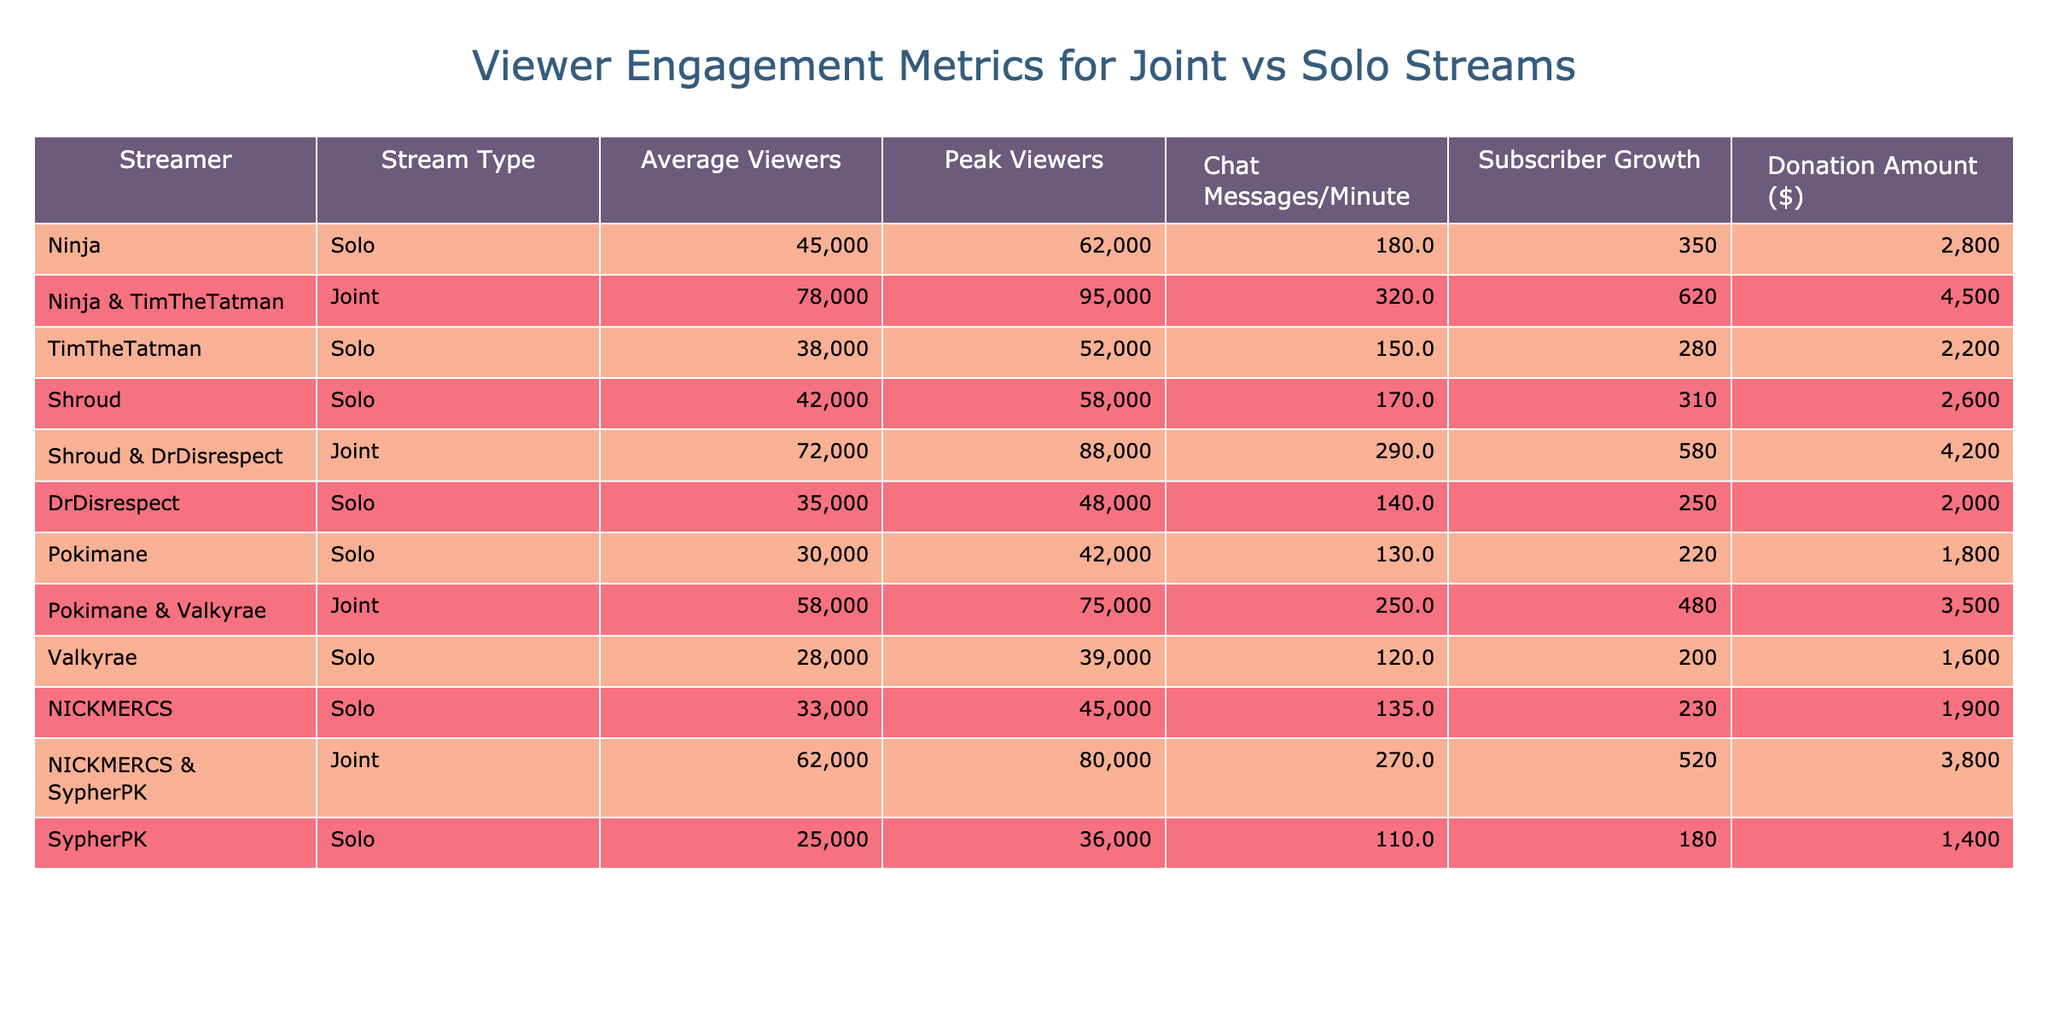What is the average number of viewers for solo streams? To find the average number of viewers for solo streams, we look at the data for solo streams: 45000, 38000, 42000, 30000, 28000, 33000, and 25000. There are 7 values, so we sum them up: 45000 + 38000 + 42000 + 30000 + 28000 + 33000 + 25000 = 211000. Dividing this total by 7 gives us an average of 211000 / 7 ≈ 30143
Answer: 30143 Which joint stream has the highest peak viewers? Looking at the joint stream data: 95000 for Ninja & TimTheTatman and 88000 for Shroud & DrDisrespect. The highest value is 95000 reached by Ninja & TimTheTatman.
Answer: 95000 How many chat messages per minute are generated in total for joint streams? The chat messages per minute for joint streams are 320, 290, 250, and 270. Adding these values gives: 320 + 290 + 250 + 270 = 1130.
Answer: 1130 Is the average donation amount for joint streams higher than for solo streams? The total donation amounts for joint streams are 4500, 4200, 3500, and 3800, totaling 16500. For solo streams, the total is 2800 + 2200 + 2600 + 1800 + 1600 + 1900 + 1400 = 14500. Since 16500 > 14500, the average for joint streams is higher.
Answer: Yes Which streamer has the highest average viewers among solo and joint streams? Examining the averages, Ninja has 45000 solo and 78000 joint. Shroud has 42000 solo and 72000 joint. TimTheTatman has 38000 solo and 78000 joint. Comparing these, Ninja and TimTheTatman both have the highest average of 78000.
Answer: 78000 What is the difference in subscriber growth between Ninja's solo and joint streams? Ninja’s solo subscriber growth is 350 and the joint stream is 620. The difference is calculated as 620 - 350 = 270.
Answer: 270 Do solo streams have a consistently higher average viewers count compared to solo streams? To determine this, we would compare the aggregates: the average for solo streams is approximately 30143, and joint streams average 63750 (calculated from their totals). Since 30143 < 63750, solo streams are not higher.
Answer: No What is the total number of average viewers for all streamers in solo streams? The average viewers for solo streams are: 45000, 38000, 42000, 30000, 28000, 33000, and 25000. Adding these together gives a total of 211000.
Answer: 211000 How does the chat engagement of the joint stream featuring Ninja and TimTheTatman compare to the solo streams of Pokimane and DrDisrespect? Ninja and TimTheTatman's joint stream has 320 chat messages per minute, while Pokimane’s solo stream has 130 and DrDisrespect’s solo has 140, giving a total of 270 for solo streams. Since 320 > 270, the joint stream has higher engagement.
Answer: Higher 